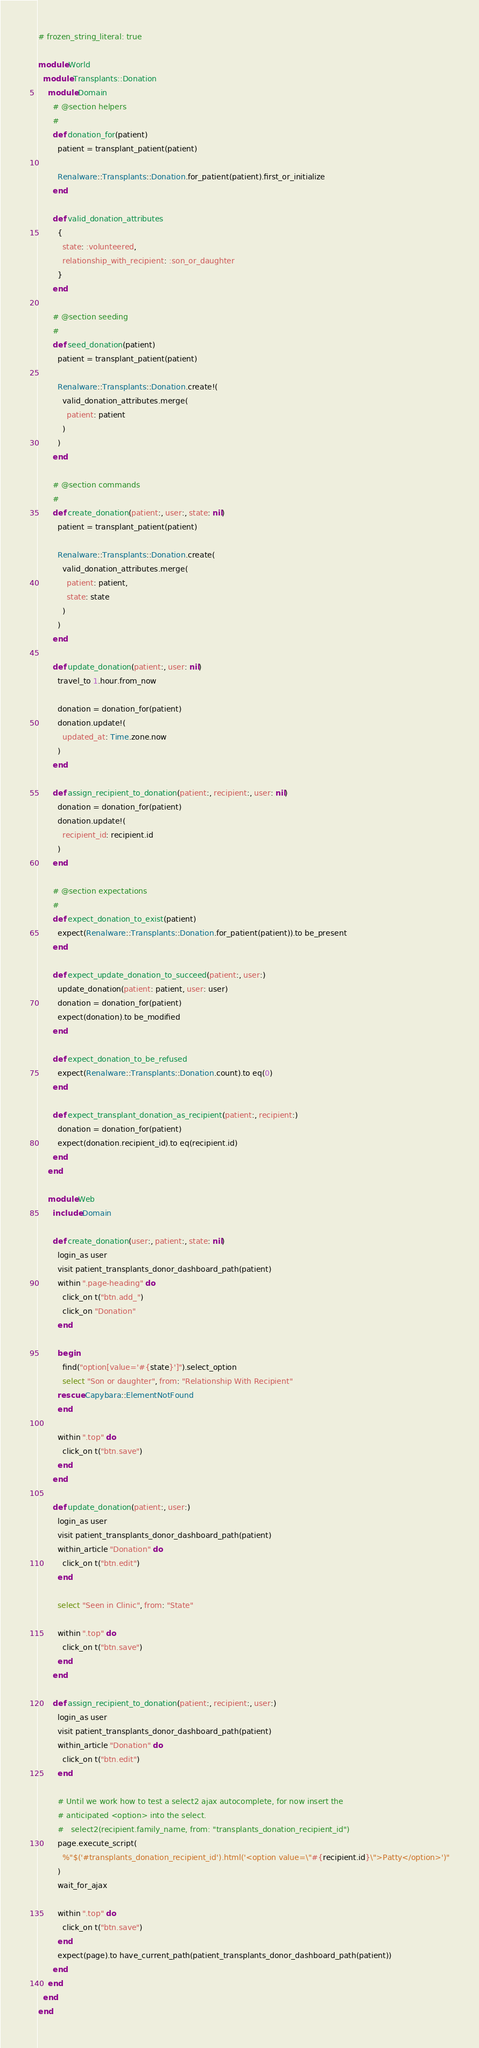<code> <loc_0><loc_0><loc_500><loc_500><_Ruby_># frozen_string_literal: true

module World
  module Transplants::Donation
    module Domain
      # @section helpers
      #
      def donation_for(patient)
        patient = transplant_patient(patient)

        Renalware::Transplants::Donation.for_patient(patient).first_or_initialize
      end

      def valid_donation_attributes
        {
          state: :volunteered,
          relationship_with_recipient: :son_or_daughter
        }
      end

      # @section seeding
      #
      def seed_donation(patient)
        patient = transplant_patient(patient)

        Renalware::Transplants::Donation.create!(
          valid_donation_attributes.merge(
            patient: patient
          )
        )
      end

      # @section commands
      #
      def create_donation(patient:, user:, state: nil)
        patient = transplant_patient(patient)

        Renalware::Transplants::Donation.create(
          valid_donation_attributes.merge(
            patient: patient,
            state: state
          )
        )
      end

      def update_donation(patient:, user: nil)
        travel_to 1.hour.from_now

        donation = donation_for(patient)
        donation.update!(
          updated_at: Time.zone.now
        )
      end

      def assign_recipient_to_donation(patient:, recipient:, user: nil)
        donation = donation_for(patient)
        donation.update!(
          recipient_id: recipient.id
        )
      end

      # @section expectations
      #
      def expect_donation_to_exist(patient)
        expect(Renalware::Transplants::Donation.for_patient(patient)).to be_present
      end

      def expect_update_donation_to_succeed(patient:, user:)
        update_donation(patient: patient, user: user)
        donation = donation_for(patient)
        expect(donation).to be_modified
      end

      def expect_donation_to_be_refused
        expect(Renalware::Transplants::Donation.count).to eq(0)
      end

      def expect_transplant_donation_as_recipient(patient:, recipient:)
        donation = donation_for(patient)
        expect(donation.recipient_id).to eq(recipient.id)
      end
    end

    module Web
      include Domain

      def create_donation(user:, patient:, state: nil)
        login_as user
        visit patient_transplants_donor_dashboard_path(patient)
        within ".page-heading" do
          click_on t("btn.add_")
          click_on "Donation"
        end

        begin
          find("option[value='#{state}']").select_option
          select "Son or daughter", from: "Relationship With Recipient"
        rescue Capybara::ElementNotFound
        end

        within ".top" do
          click_on t("btn.save")
        end
      end

      def update_donation(patient:, user:)
        login_as user
        visit patient_transplants_donor_dashboard_path(patient)
        within_article "Donation" do
          click_on t("btn.edit")
        end

        select "Seen in Clinic", from: "State"

        within ".top" do
          click_on t("btn.save")
        end
      end

      def assign_recipient_to_donation(patient:, recipient:, user:)
        login_as user
        visit patient_transplants_donor_dashboard_path(patient)
        within_article "Donation" do
          click_on t("btn.edit")
        end

        # Until we work how to test a select2 ajax autocomplete, for now insert the
        # anticipated <option> into the select.
        #   select2(recipient.family_name, from: "transplants_donation_recipient_id")
        page.execute_script(
          %"$('#transplants_donation_recipient_id').html('<option value=\"#{recipient.id}\">Patty</option>')"
        )
        wait_for_ajax

        within ".top" do
          click_on t("btn.save")
        end
        expect(page).to have_current_path(patient_transplants_donor_dashboard_path(patient))
      end
    end
  end
end
</code> 